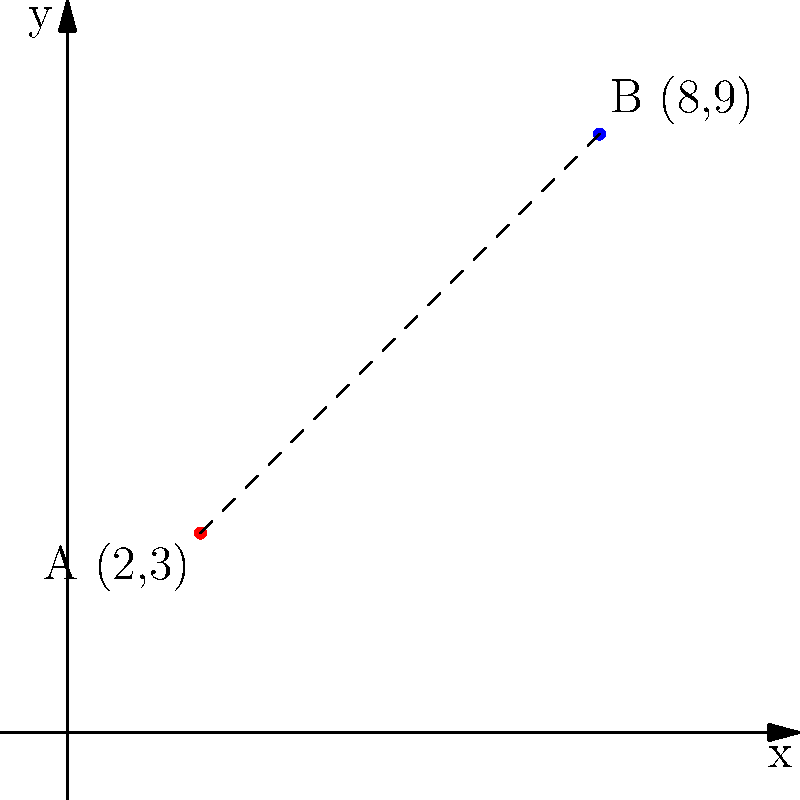As a landlord, you're considering purchasing two apartment buildings in different parts of the city. The locations of these buildings can be represented on a coordinate grid. Building A is located at (2,3) and Building B is at (8,9). What is the straight-line distance between these two buildings? Round your answer to the nearest whole number. To find the distance between two points on a coordinate plane, we can use the distance formula, which is derived from the Pythagorean theorem:

$$ d = \sqrt{(x_2 - x_1)^2 + (y_2 - y_1)^2} $$

Where $(x_1, y_1)$ are the coordinates of the first point and $(x_2, y_2)$ are the coordinates of the second point.

Let's plug in our values:
$(x_1, y_1) = (2, 3)$ for Building A
$(x_2, y_2) = (8, 9)$ for Building B

$$ d = \sqrt{(8 - 2)^2 + (9 - 3)^2} $$

$$ d = \sqrt{6^2 + 6^2} $$

$$ d = \sqrt{36 + 36} $$

$$ d = \sqrt{72} $$

$$ d \approx 8.485 $$

Rounding to the nearest whole number, we get 8.
Answer: 8 units 